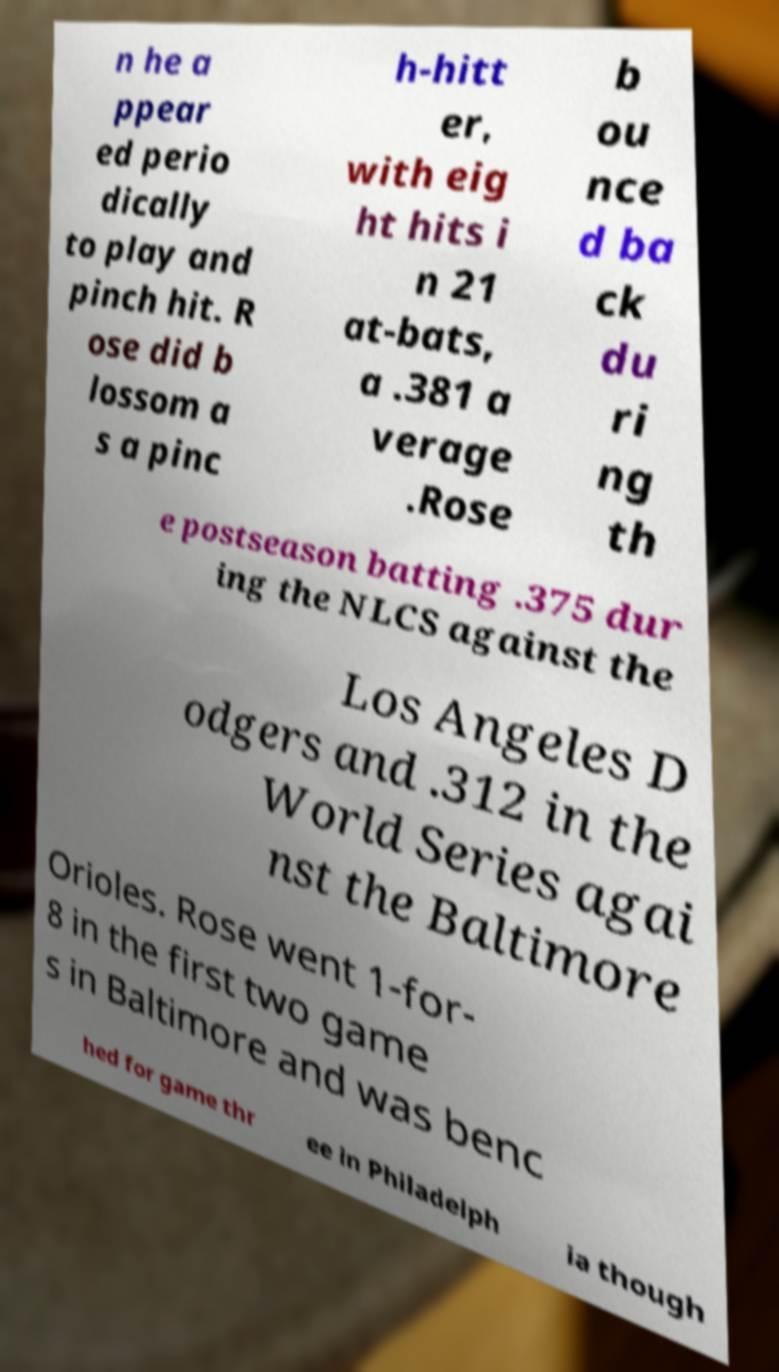I need the written content from this picture converted into text. Can you do that? n he a ppear ed perio dically to play and pinch hit. R ose did b lossom a s a pinc h-hitt er, with eig ht hits i n 21 at-bats, a .381 a verage .Rose b ou nce d ba ck du ri ng th e postseason batting .375 dur ing the NLCS against the Los Angeles D odgers and .312 in the World Series agai nst the Baltimore Orioles. Rose went 1-for- 8 in the first two game s in Baltimore and was benc hed for game thr ee in Philadelph ia though 